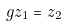<formula> <loc_0><loc_0><loc_500><loc_500>g z _ { 1 } = z _ { 2 }</formula> 